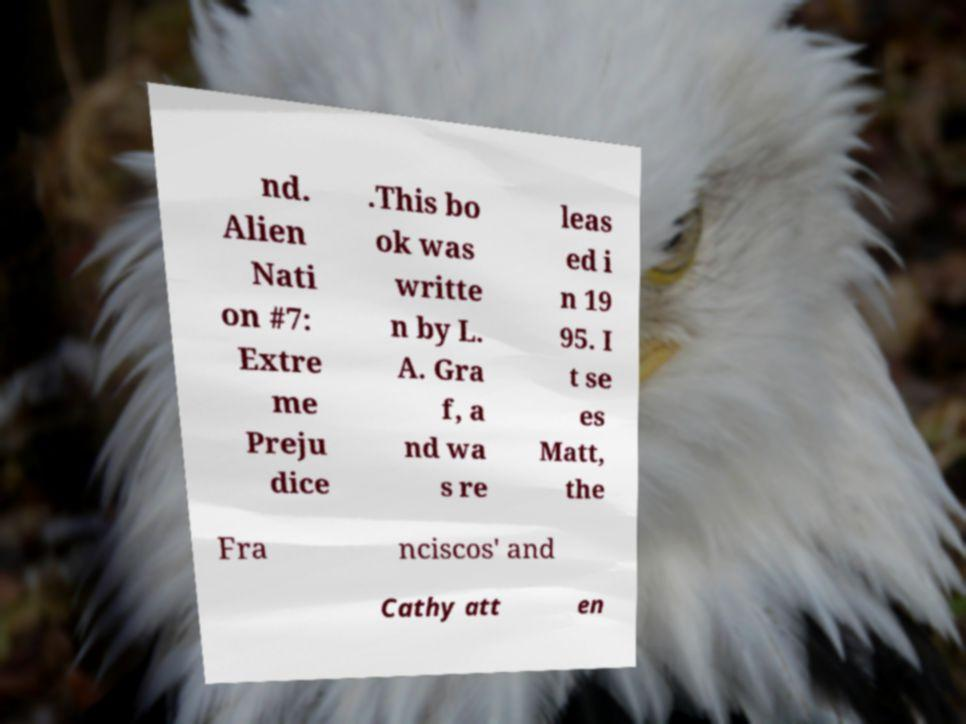Please read and relay the text visible in this image. What does it say? nd. Alien Nati on #7: Extre me Preju dice .This bo ok was writte n by L. A. Gra f, a nd wa s re leas ed i n 19 95. I t se es Matt, the Fra nciscos' and Cathy att en 